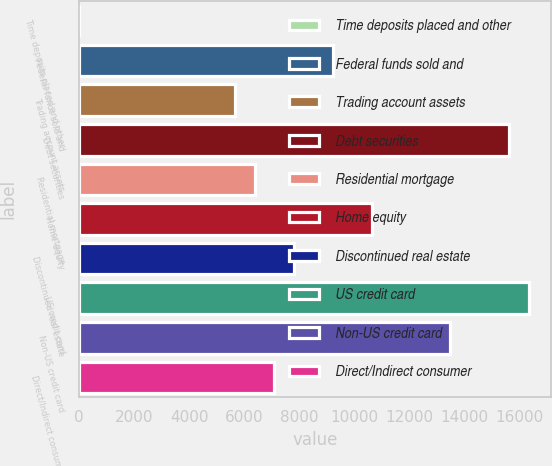<chart> <loc_0><loc_0><loc_500><loc_500><bar_chart><fcel>Time deposits placed and other<fcel>Federal funds sold and<fcel>Trading account assets<fcel>Debt securities<fcel>Residential mortgage<fcel>Home equity<fcel>Discontinued real estate<fcel>US credit card<fcel>Non-US credit card<fcel>Direct/Indirect consumer<nl><fcel>1<fcel>9225.8<fcel>5677.8<fcel>15612.2<fcel>6387.4<fcel>10645<fcel>7806.6<fcel>16321.8<fcel>13483.4<fcel>7097<nl></chart> 